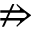Convert formula to latex. <formula><loc_0><loc_0><loc_500><loc_500>\ n R i g h t a r r o w</formula> 